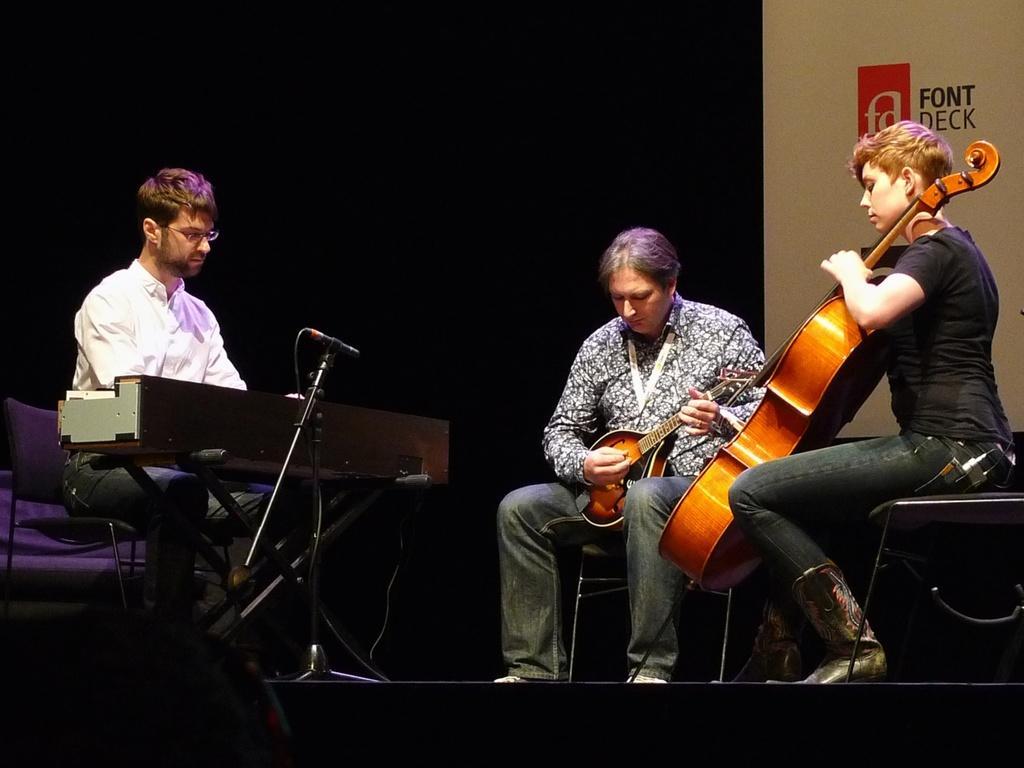Please provide a concise description of this image. In this image, 3 peoples are sat on the chair. They are playing a musical instrument in-front of microphone. On right side, we can see a banner. We can see a stage here. The art strands and wires are there. 